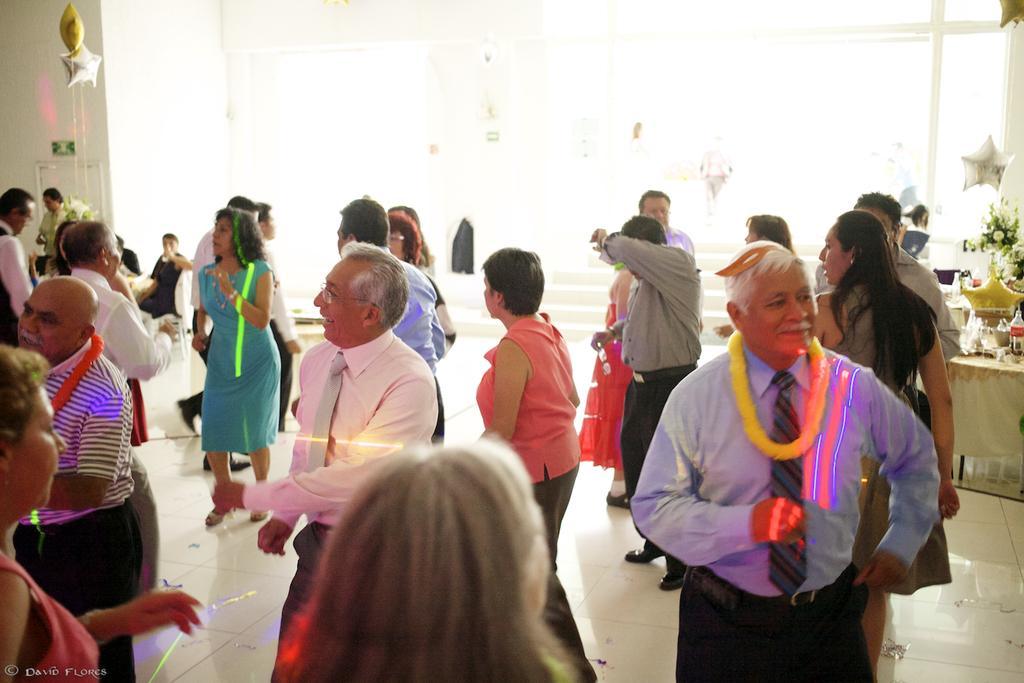Can you describe this image briefly? In this image I see number of people in which this man is smiling and I see the floor. In the background I see few people over here who are sitting on chairs and I see the stars and on this table I see bottles, glasses and few other things and it is white over here. 